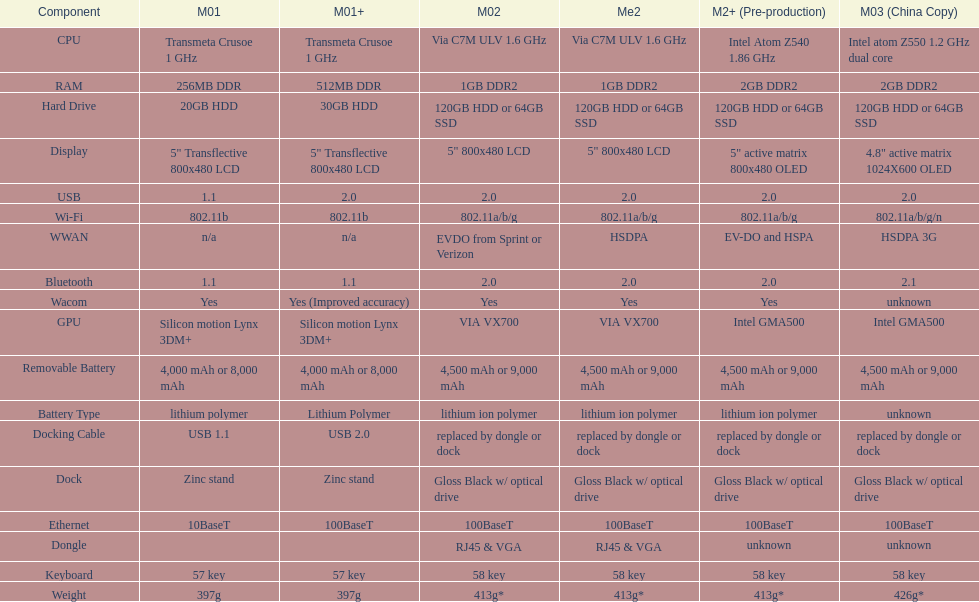How many models use a usb docking cable? 2. 